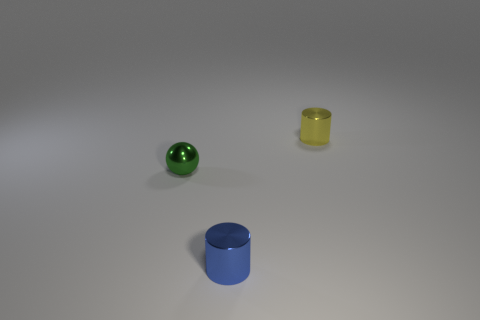Are there any small purple cubes that have the same material as the tiny yellow cylinder?
Your response must be concise. No. What color is the other object that is the same shape as the small yellow object?
Ensure brevity in your answer.  Blue. Are the yellow cylinder and the object that is left of the small blue metal cylinder made of the same material?
Offer a terse response. Yes. What is the shape of the shiny thing behind the small shiny object left of the small blue metal thing?
Your response must be concise. Cylinder. Is the size of the metallic cylinder in front of the green metallic ball the same as the small green shiny ball?
Provide a short and direct response. Yes. How many other things are there of the same shape as the green metal thing?
Give a very brief answer. 0. There is a tiny cylinder that is behind the metal ball; is it the same color as the sphere?
Provide a succinct answer. No. Is there another small metal ball that has the same color as the sphere?
Ensure brevity in your answer.  No. There is a tiny metallic ball; how many blue metal things are right of it?
Make the answer very short. 1. Does the tiny thing in front of the sphere have the same material as the small cylinder behind the small blue cylinder?
Make the answer very short. Yes. 